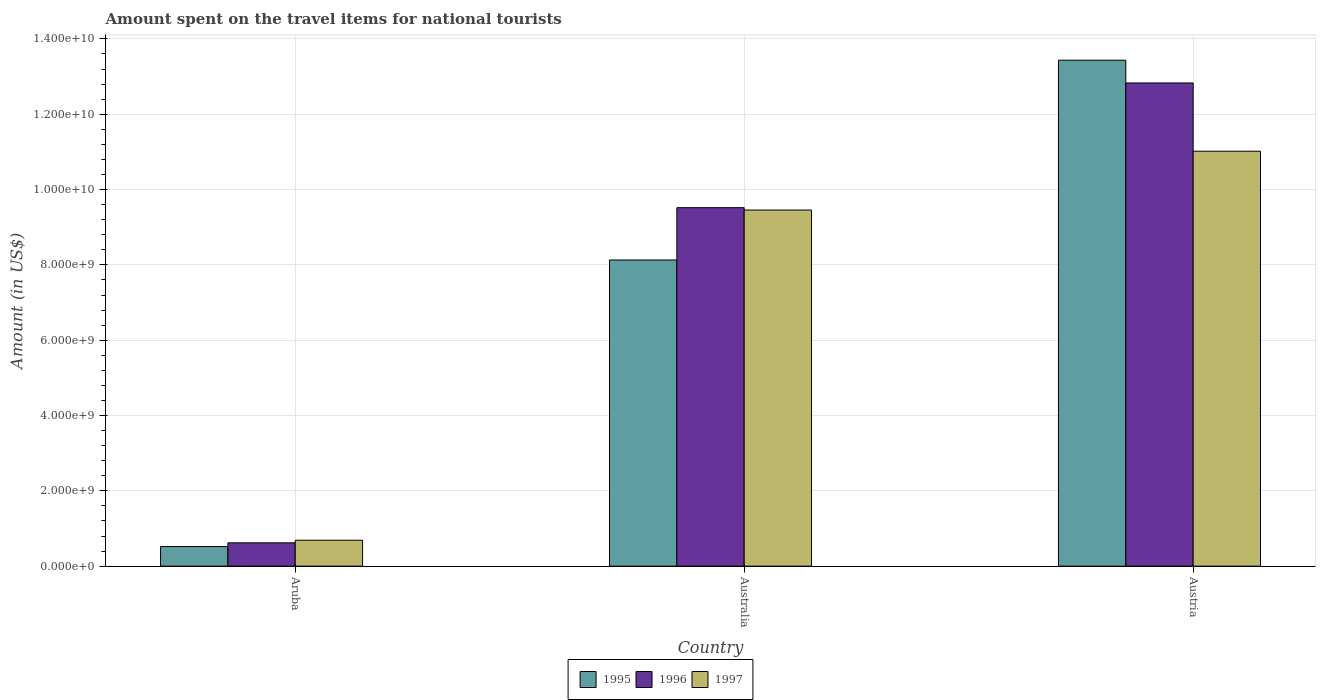Are the number of bars on each tick of the X-axis equal?
Keep it short and to the point. Yes. What is the amount spent on the travel items for national tourists in 1997 in Austria?
Make the answer very short. 1.10e+1. Across all countries, what is the maximum amount spent on the travel items for national tourists in 1997?
Provide a succinct answer. 1.10e+1. Across all countries, what is the minimum amount spent on the travel items for national tourists in 1996?
Your answer should be very brief. 6.20e+08. In which country was the amount spent on the travel items for national tourists in 1996 minimum?
Your response must be concise. Aruba. What is the total amount spent on the travel items for national tourists in 1995 in the graph?
Give a very brief answer. 2.21e+1. What is the difference between the amount spent on the travel items for national tourists in 1995 in Aruba and that in Austria?
Give a very brief answer. -1.29e+1. What is the difference between the amount spent on the travel items for national tourists in 1995 in Austria and the amount spent on the travel items for national tourists in 1996 in Aruba?
Make the answer very short. 1.28e+1. What is the average amount spent on the travel items for national tourists in 1995 per country?
Provide a succinct answer. 7.36e+09. What is the difference between the amount spent on the travel items for national tourists of/in 1995 and amount spent on the travel items for national tourists of/in 1996 in Aruba?
Your answer should be compact. -9.90e+07. What is the ratio of the amount spent on the travel items for national tourists in 1996 in Aruba to that in Australia?
Keep it short and to the point. 0.07. Is the amount spent on the travel items for national tourists in 1996 in Aruba less than that in Austria?
Your response must be concise. Yes. What is the difference between the highest and the second highest amount spent on the travel items for national tourists in 1997?
Your response must be concise. 1.56e+09. What is the difference between the highest and the lowest amount spent on the travel items for national tourists in 1996?
Provide a succinct answer. 1.22e+1. In how many countries, is the amount spent on the travel items for national tourists in 1996 greater than the average amount spent on the travel items for national tourists in 1996 taken over all countries?
Offer a terse response. 2. How many countries are there in the graph?
Your response must be concise. 3. Are the values on the major ticks of Y-axis written in scientific E-notation?
Offer a very short reply. Yes. Does the graph contain any zero values?
Your answer should be very brief. No. Where does the legend appear in the graph?
Your answer should be compact. Bottom center. How many legend labels are there?
Make the answer very short. 3. How are the legend labels stacked?
Provide a succinct answer. Horizontal. What is the title of the graph?
Offer a terse response. Amount spent on the travel items for national tourists. What is the label or title of the Y-axis?
Give a very brief answer. Amount (in US$). What is the Amount (in US$) of 1995 in Aruba?
Provide a succinct answer. 5.21e+08. What is the Amount (in US$) in 1996 in Aruba?
Give a very brief answer. 6.20e+08. What is the Amount (in US$) of 1997 in Aruba?
Provide a succinct answer. 6.89e+08. What is the Amount (in US$) of 1995 in Australia?
Provide a short and direct response. 8.13e+09. What is the Amount (in US$) in 1996 in Australia?
Your answer should be very brief. 9.52e+09. What is the Amount (in US$) in 1997 in Australia?
Your response must be concise. 9.46e+09. What is the Amount (in US$) of 1995 in Austria?
Offer a very short reply. 1.34e+1. What is the Amount (in US$) of 1996 in Austria?
Keep it short and to the point. 1.28e+1. What is the Amount (in US$) of 1997 in Austria?
Give a very brief answer. 1.10e+1. Across all countries, what is the maximum Amount (in US$) in 1995?
Ensure brevity in your answer.  1.34e+1. Across all countries, what is the maximum Amount (in US$) in 1996?
Offer a very short reply. 1.28e+1. Across all countries, what is the maximum Amount (in US$) in 1997?
Ensure brevity in your answer.  1.10e+1. Across all countries, what is the minimum Amount (in US$) in 1995?
Your answer should be compact. 5.21e+08. Across all countries, what is the minimum Amount (in US$) of 1996?
Keep it short and to the point. 6.20e+08. Across all countries, what is the minimum Amount (in US$) of 1997?
Make the answer very short. 6.89e+08. What is the total Amount (in US$) in 1995 in the graph?
Give a very brief answer. 2.21e+1. What is the total Amount (in US$) in 1996 in the graph?
Keep it short and to the point. 2.30e+1. What is the total Amount (in US$) in 1997 in the graph?
Offer a very short reply. 2.12e+1. What is the difference between the Amount (in US$) in 1995 in Aruba and that in Australia?
Your answer should be very brief. -7.61e+09. What is the difference between the Amount (in US$) of 1996 in Aruba and that in Australia?
Make the answer very short. -8.90e+09. What is the difference between the Amount (in US$) of 1997 in Aruba and that in Australia?
Keep it short and to the point. -8.77e+09. What is the difference between the Amount (in US$) in 1995 in Aruba and that in Austria?
Your response must be concise. -1.29e+1. What is the difference between the Amount (in US$) of 1996 in Aruba and that in Austria?
Ensure brevity in your answer.  -1.22e+1. What is the difference between the Amount (in US$) in 1997 in Aruba and that in Austria?
Offer a very short reply. -1.03e+1. What is the difference between the Amount (in US$) of 1995 in Australia and that in Austria?
Ensure brevity in your answer.  -5.30e+09. What is the difference between the Amount (in US$) in 1996 in Australia and that in Austria?
Offer a terse response. -3.31e+09. What is the difference between the Amount (in US$) in 1997 in Australia and that in Austria?
Your response must be concise. -1.56e+09. What is the difference between the Amount (in US$) of 1995 in Aruba and the Amount (in US$) of 1996 in Australia?
Your answer should be compact. -9.00e+09. What is the difference between the Amount (in US$) in 1995 in Aruba and the Amount (in US$) in 1997 in Australia?
Offer a terse response. -8.94e+09. What is the difference between the Amount (in US$) of 1996 in Aruba and the Amount (in US$) of 1997 in Australia?
Your answer should be very brief. -8.84e+09. What is the difference between the Amount (in US$) in 1995 in Aruba and the Amount (in US$) in 1996 in Austria?
Give a very brief answer. -1.23e+1. What is the difference between the Amount (in US$) in 1995 in Aruba and the Amount (in US$) in 1997 in Austria?
Offer a terse response. -1.05e+1. What is the difference between the Amount (in US$) of 1996 in Aruba and the Amount (in US$) of 1997 in Austria?
Your answer should be very brief. -1.04e+1. What is the difference between the Amount (in US$) of 1995 in Australia and the Amount (in US$) of 1996 in Austria?
Provide a short and direct response. -4.70e+09. What is the difference between the Amount (in US$) in 1995 in Australia and the Amount (in US$) in 1997 in Austria?
Your answer should be compact. -2.89e+09. What is the difference between the Amount (in US$) of 1996 in Australia and the Amount (in US$) of 1997 in Austria?
Your response must be concise. -1.50e+09. What is the average Amount (in US$) in 1995 per country?
Offer a very short reply. 7.36e+09. What is the average Amount (in US$) of 1996 per country?
Provide a short and direct response. 7.66e+09. What is the average Amount (in US$) in 1997 per country?
Your answer should be compact. 7.05e+09. What is the difference between the Amount (in US$) of 1995 and Amount (in US$) of 1996 in Aruba?
Make the answer very short. -9.90e+07. What is the difference between the Amount (in US$) of 1995 and Amount (in US$) of 1997 in Aruba?
Your response must be concise. -1.68e+08. What is the difference between the Amount (in US$) of 1996 and Amount (in US$) of 1997 in Aruba?
Provide a succinct answer. -6.90e+07. What is the difference between the Amount (in US$) in 1995 and Amount (in US$) in 1996 in Australia?
Provide a short and direct response. -1.39e+09. What is the difference between the Amount (in US$) in 1995 and Amount (in US$) in 1997 in Australia?
Offer a terse response. -1.33e+09. What is the difference between the Amount (in US$) of 1996 and Amount (in US$) of 1997 in Australia?
Your answer should be very brief. 6.30e+07. What is the difference between the Amount (in US$) of 1995 and Amount (in US$) of 1996 in Austria?
Provide a short and direct response. 6.05e+08. What is the difference between the Amount (in US$) of 1995 and Amount (in US$) of 1997 in Austria?
Make the answer very short. 2.42e+09. What is the difference between the Amount (in US$) in 1996 and Amount (in US$) in 1997 in Austria?
Give a very brief answer. 1.81e+09. What is the ratio of the Amount (in US$) in 1995 in Aruba to that in Australia?
Your answer should be very brief. 0.06. What is the ratio of the Amount (in US$) in 1996 in Aruba to that in Australia?
Ensure brevity in your answer.  0.07. What is the ratio of the Amount (in US$) in 1997 in Aruba to that in Australia?
Keep it short and to the point. 0.07. What is the ratio of the Amount (in US$) of 1995 in Aruba to that in Austria?
Offer a terse response. 0.04. What is the ratio of the Amount (in US$) of 1996 in Aruba to that in Austria?
Offer a very short reply. 0.05. What is the ratio of the Amount (in US$) of 1997 in Aruba to that in Austria?
Your answer should be compact. 0.06. What is the ratio of the Amount (in US$) in 1995 in Australia to that in Austria?
Your response must be concise. 0.61. What is the ratio of the Amount (in US$) of 1996 in Australia to that in Austria?
Give a very brief answer. 0.74. What is the ratio of the Amount (in US$) of 1997 in Australia to that in Austria?
Give a very brief answer. 0.86. What is the difference between the highest and the second highest Amount (in US$) of 1995?
Provide a succinct answer. 5.30e+09. What is the difference between the highest and the second highest Amount (in US$) in 1996?
Provide a succinct answer. 3.31e+09. What is the difference between the highest and the second highest Amount (in US$) of 1997?
Give a very brief answer. 1.56e+09. What is the difference between the highest and the lowest Amount (in US$) of 1995?
Offer a very short reply. 1.29e+1. What is the difference between the highest and the lowest Amount (in US$) of 1996?
Offer a very short reply. 1.22e+1. What is the difference between the highest and the lowest Amount (in US$) in 1997?
Your answer should be compact. 1.03e+1. 